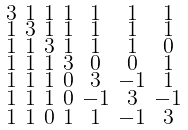<formula> <loc_0><loc_0><loc_500><loc_500>\begin{smallmatrix} 3 & 1 & 1 & 1 & 1 & 1 & 1 \\ 1 & 3 & 1 & 1 & 1 & 1 & 1 \\ 1 & 1 & 3 & 1 & 1 & 1 & 0 \\ 1 & 1 & 1 & 3 & 0 & 0 & 1 \\ 1 & 1 & 1 & 0 & 3 & - 1 & 1 \\ 1 & 1 & 1 & 0 & - 1 & 3 & - 1 \\ 1 & 1 & 0 & 1 & 1 & - 1 & 3 \end{smallmatrix}</formula> 